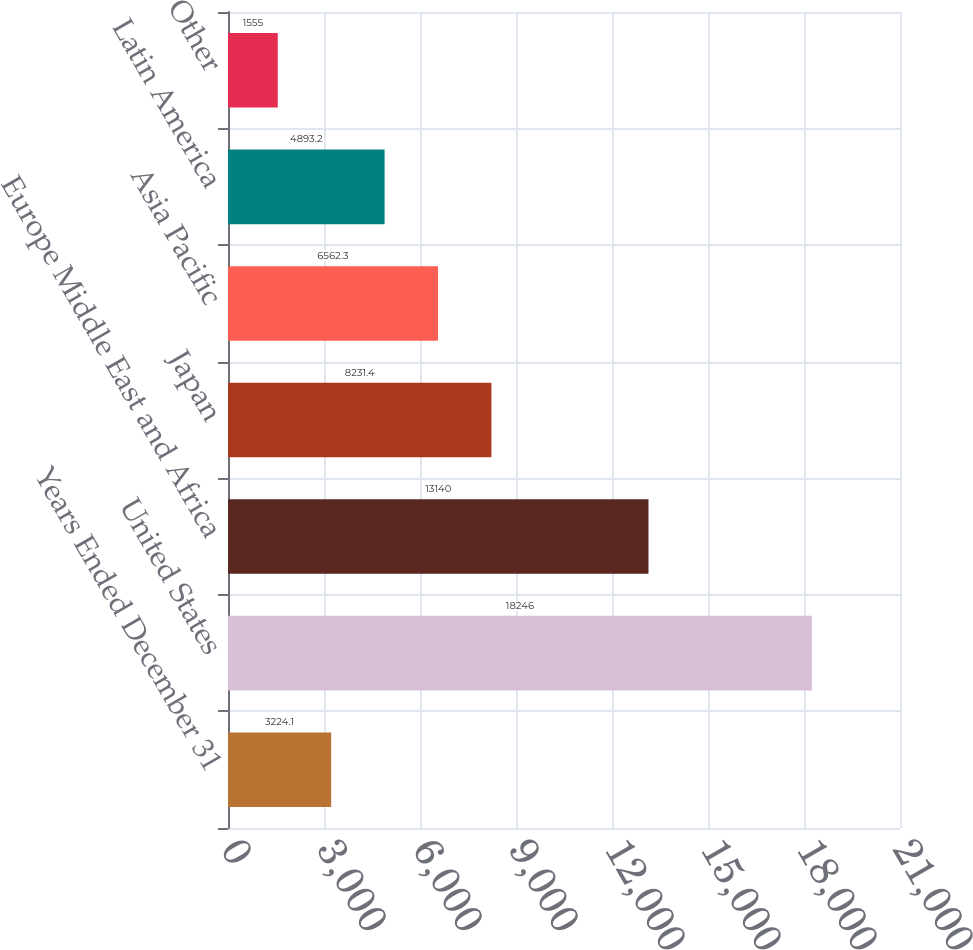Convert chart. <chart><loc_0><loc_0><loc_500><loc_500><bar_chart><fcel>Years Ended December 31<fcel>United States<fcel>Europe Middle East and Africa<fcel>Japan<fcel>Asia Pacific<fcel>Latin America<fcel>Other<nl><fcel>3224.1<fcel>18246<fcel>13140<fcel>8231.4<fcel>6562.3<fcel>4893.2<fcel>1555<nl></chart> 